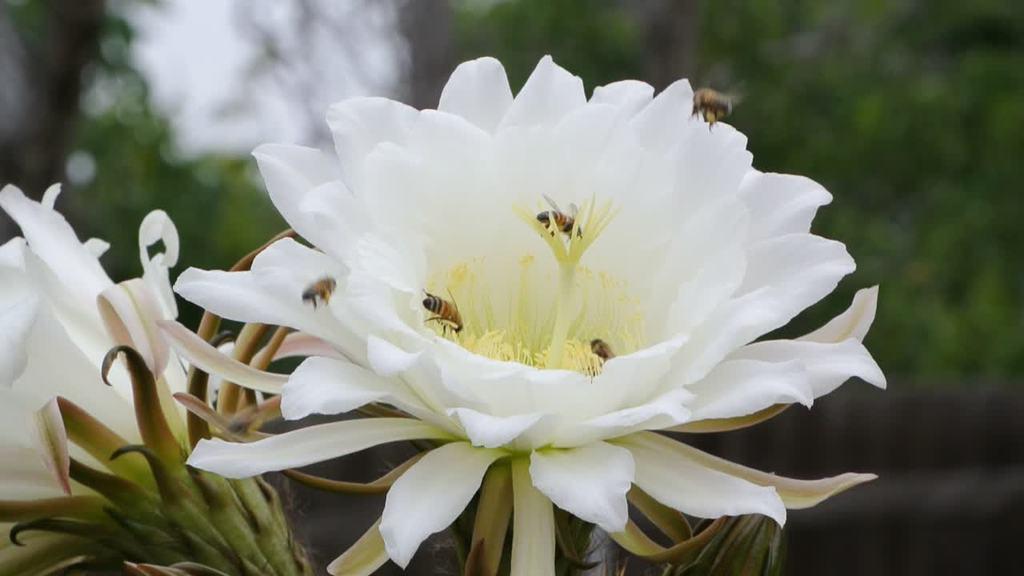Can you describe this image briefly? In this image I can see a flower. I can see few insects on the flower. The background is blurry. 